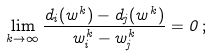Convert formula to latex. <formula><loc_0><loc_0><loc_500><loc_500>\lim _ { k \to \infty } \frac { d _ { i } ( w ^ { k } ) - d _ { j } ( w ^ { k } ) } { w ^ { k } _ { i } - w ^ { k } _ { j } } = 0 \, ;</formula> 